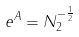<formula> <loc_0><loc_0><loc_500><loc_500>e ^ { A } = N _ { 2 } ^ { - \frac { 1 } { 2 } }</formula> 